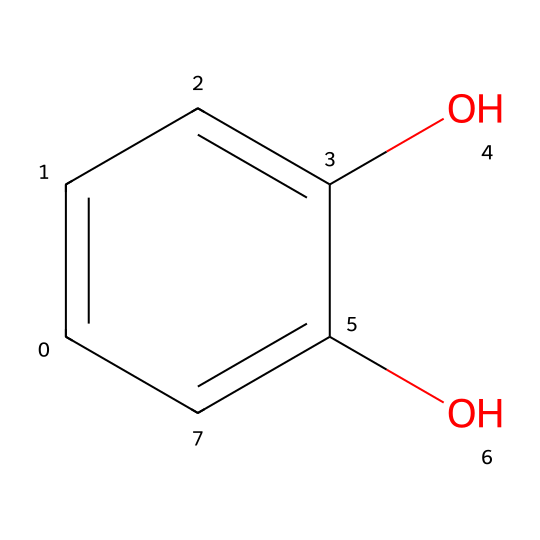What is the name of this chemical? The SMILES representation indicates that the structure contains two hydroxyl (-OH) groups attached to a benzene ring, which defines catechol.
Answer: catechol How many hydroxyl groups are present in the molecule? By examining the chemical structure, we can see two -OH groups attached to the benzene ring.
Answer: 2 How many carbon atoms are present in catechol? The benzene ring consists of six carbon atoms, and there are no additional carbon atoms outside the ring, so the total is six.
Answer: 6 What type of chemical bond connects the carbon atoms in the ring? The carbon atoms in the benzene ring are interconnected through alternating single and double bonds forming a resonance structure typical of aromatic compounds.
Answer: aromatic bonds What functional group is present in catechol? The presence of the hydroxyl groups (-OH) is defining for catechol, identifying it as a phenol.
Answer: hydroxyl groups What effect do the hydroxyl groups have on the solubility of catechol? Hydroxyl groups are polar and can form hydrogen bonds with water, increasing catechol's solubility in polar solvents like water.
Answer: increases solubility What type of isomerism can catechol exhibit? Catechol can exhibit positional isomerism due to the different locations of hydroxyl groups on the benzene ring, such as in resorcinol or hydroquinone.
Answer: positional isomerism 